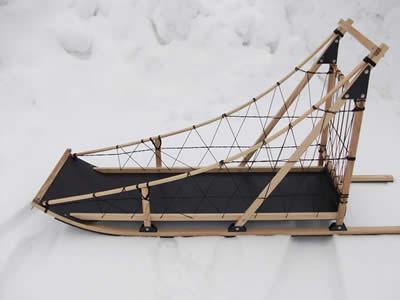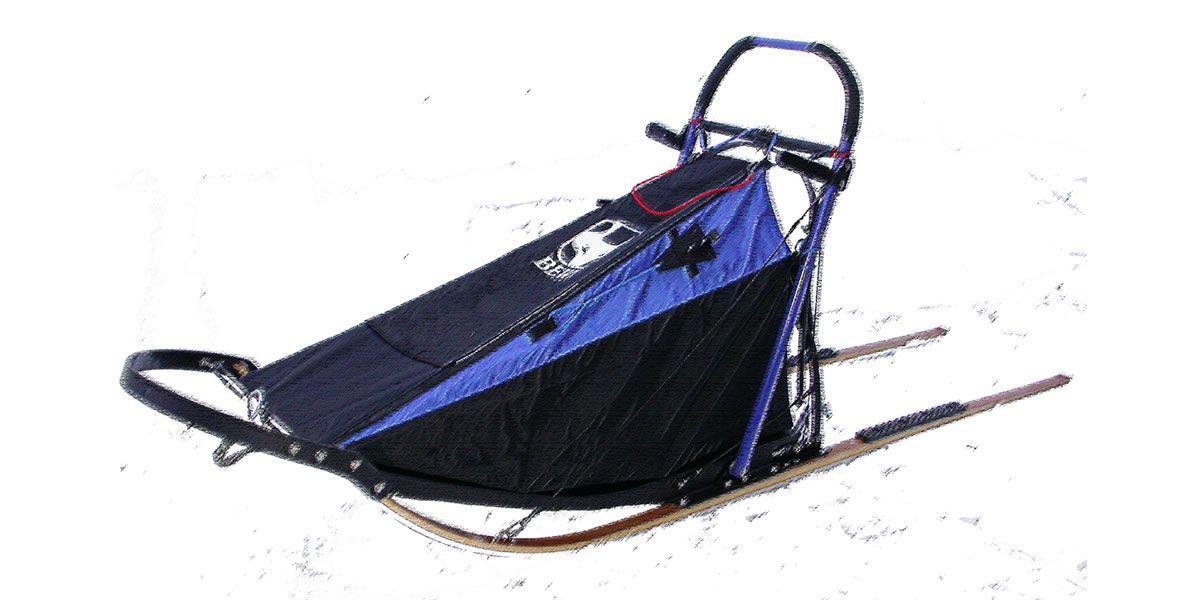The first image is the image on the left, the second image is the image on the right. Considering the images on both sides, is "There is exactly one sled in every photo, with one being made of wood with open design and black bottom and the other made with a tent material that is closed." valid? Answer yes or no. Yes. The first image is the image on the left, the second image is the image on the right. Given the left and right images, does the statement "The left image contains an empty, uncovered wood-framed sled with a straight bar for a handle, netting on the sides and a black base, and the right image contains a sled with a nylon cover and curved handle." hold true? Answer yes or no. Yes. 